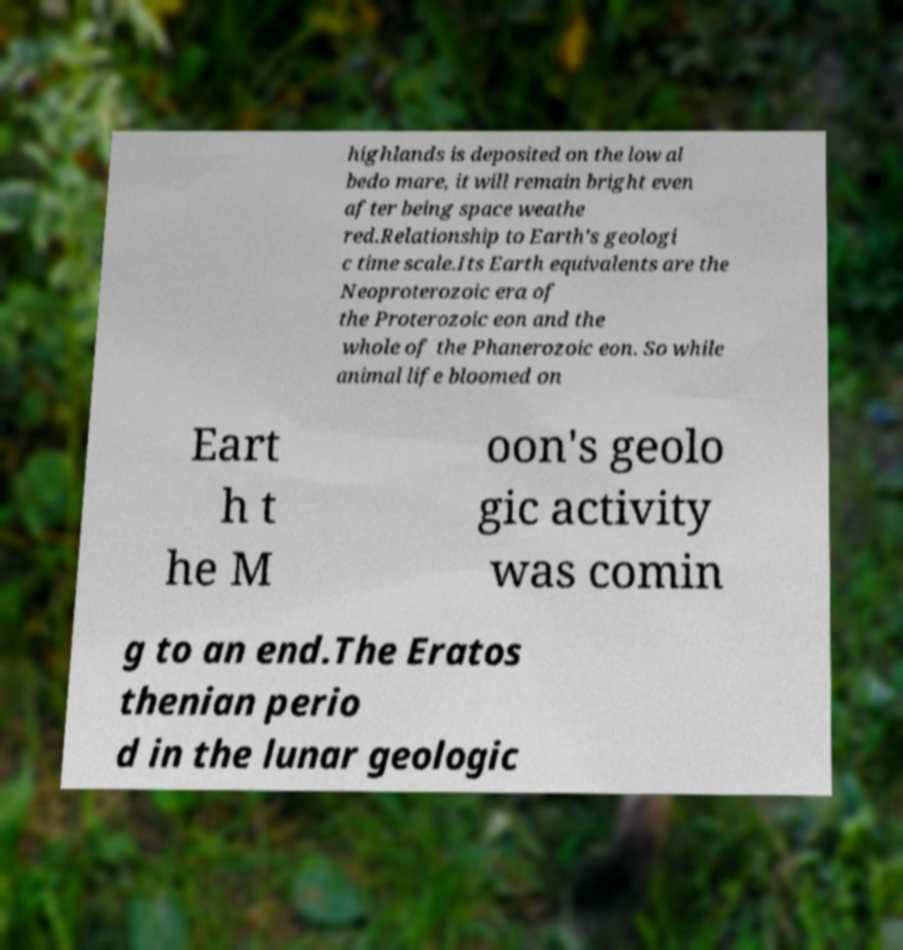What messages or text are displayed in this image? I need them in a readable, typed format. highlands is deposited on the low al bedo mare, it will remain bright even after being space weathe red.Relationship to Earth's geologi c time scale.Its Earth equivalents are the Neoproterozoic era of the Proterozoic eon and the whole of the Phanerozoic eon. So while animal life bloomed on Eart h t he M oon's geolo gic activity was comin g to an end.The Eratos thenian perio d in the lunar geologic 